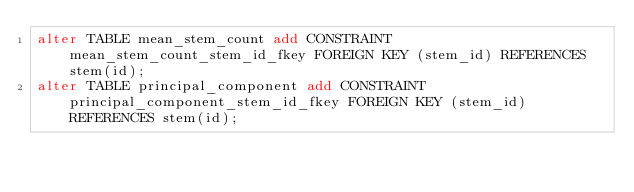Convert code to text. <code><loc_0><loc_0><loc_500><loc_500><_SQL_>alter TABLE mean_stem_count add CONSTRAINT mean_stem_count_stem_id_fkey FOREIGN KEY (stem_id) REFERENCES stem(id);
alter TABLE principal_component add CONSTRAINT principal_component_stem_id_fkey FOREIGN KEY (stem_id) REFERENCES stem(id);

</code> 